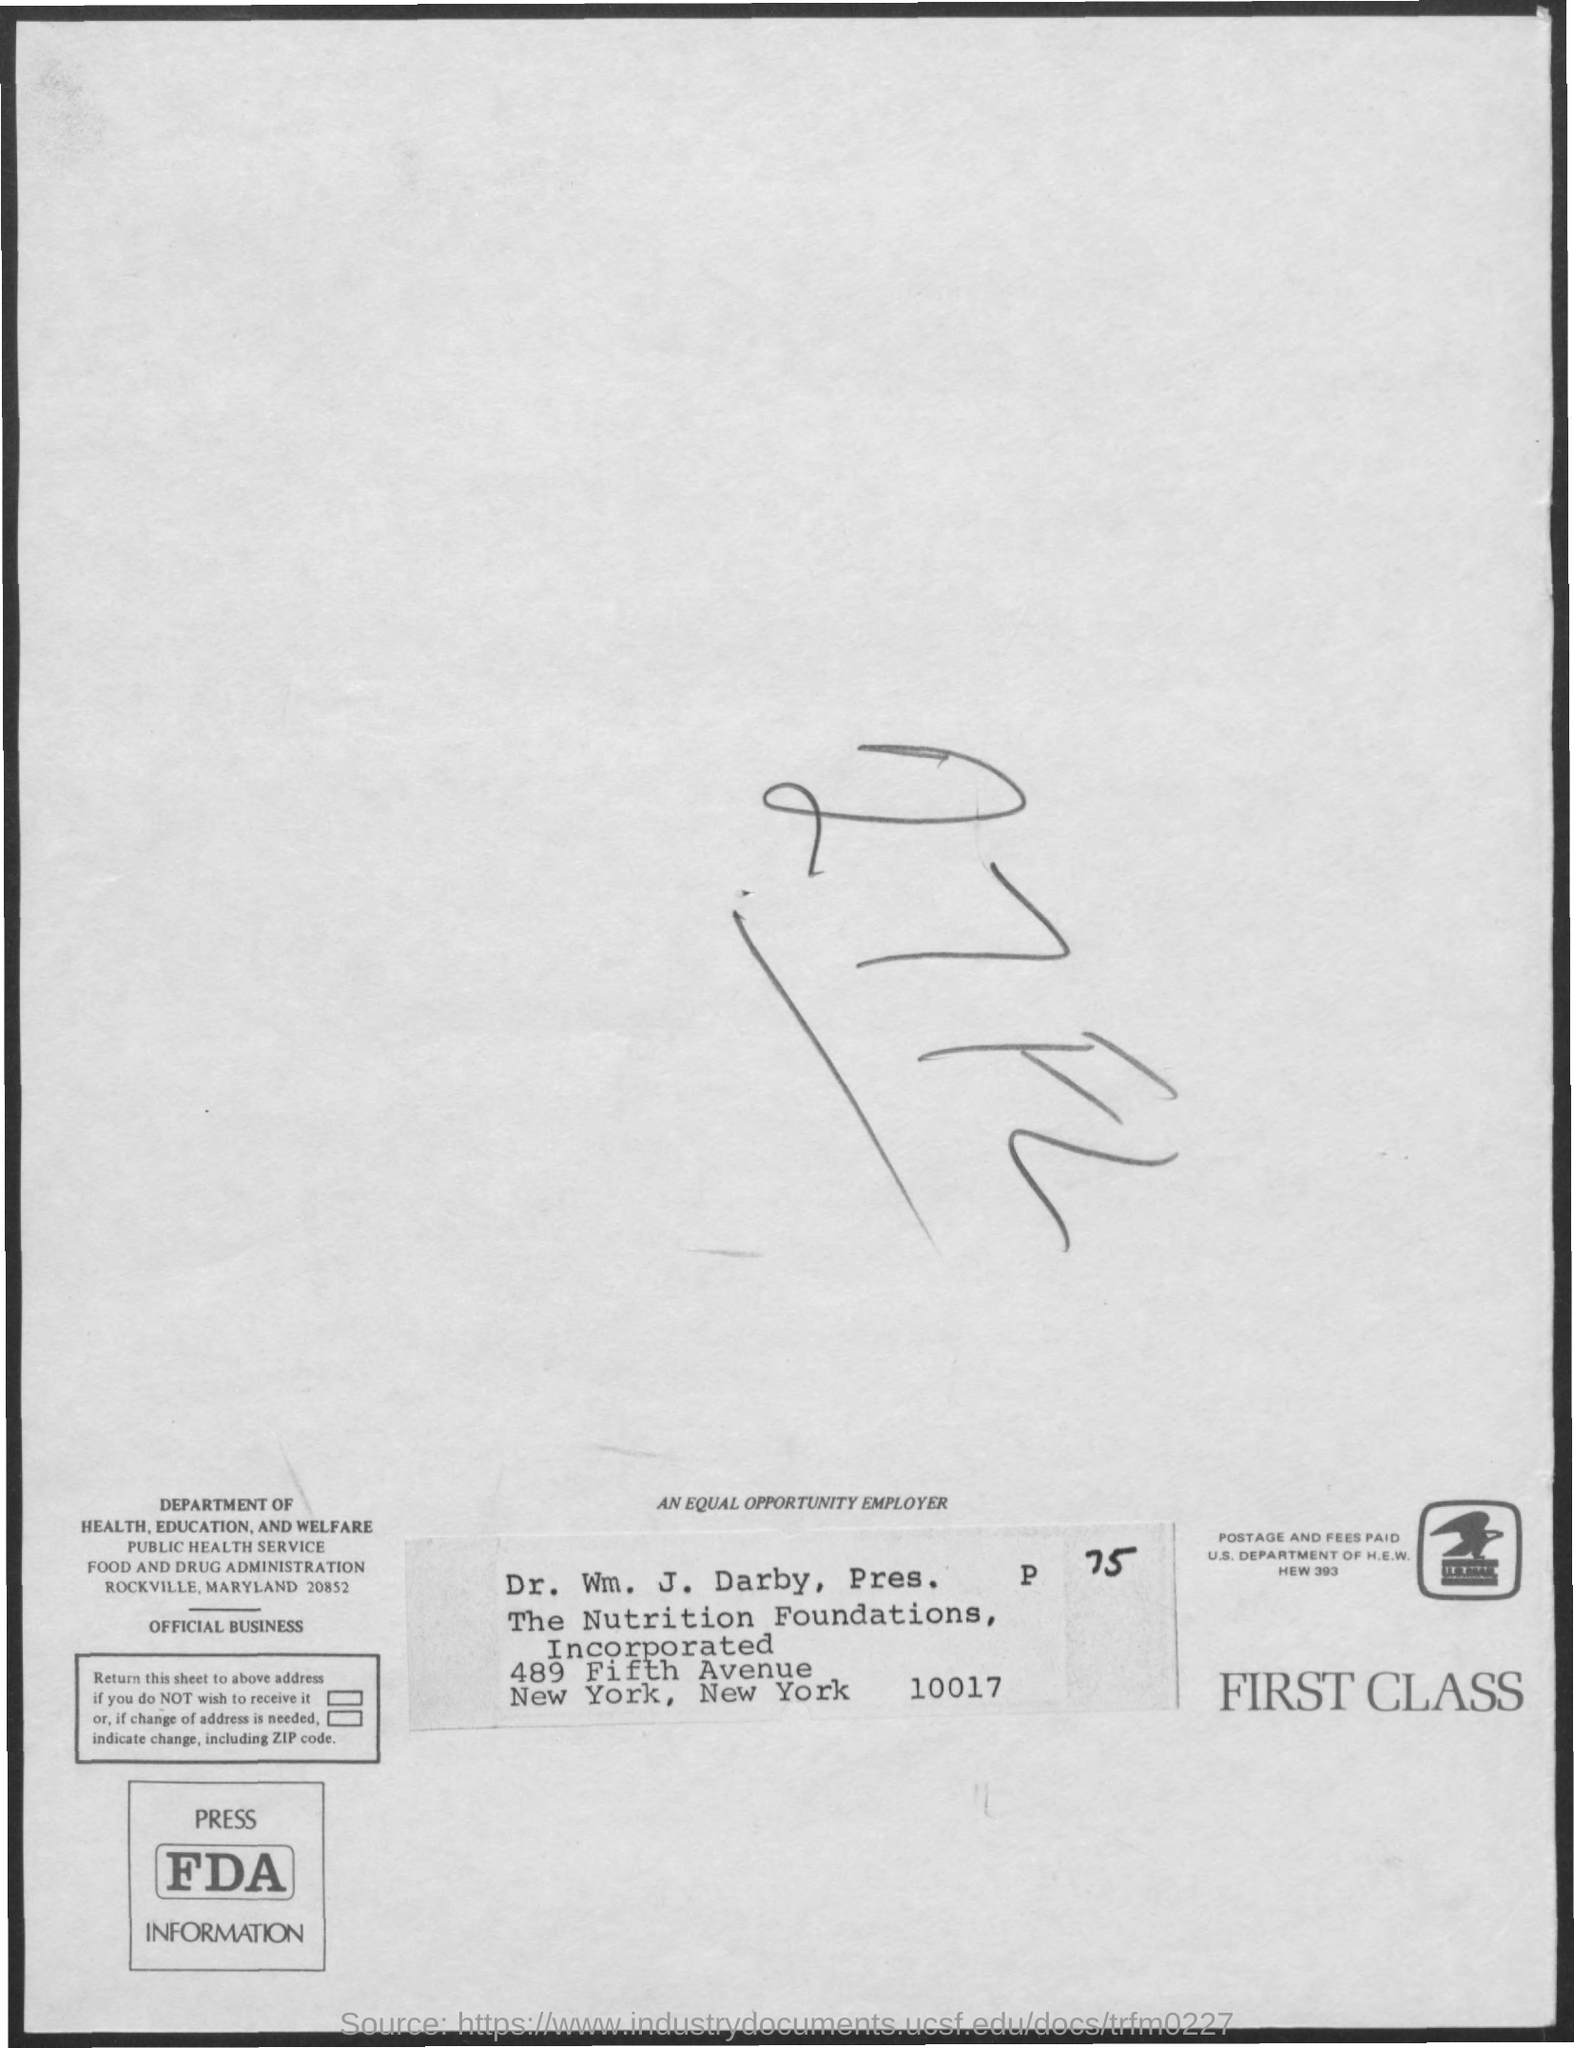What is handwritten in the document?
Keep it short and to the point. 27FL. 